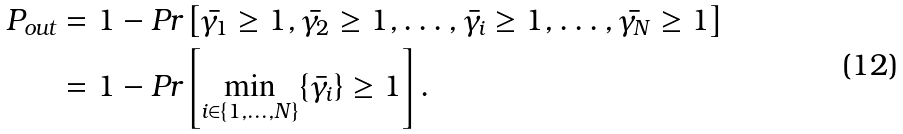<formula> <loc_0><loc_0><loc_500><loc_500>P _ { o u t } & = 1 - P r \left [ \bar { \gamma _ { 1 } } \geq 1 , \bar { \gamma _ { 2 } } \geq 1 , \dots , \bar { \gamma _ { i } } \geq 1 , \dots , \bar { \gamma _ { N } } \geq 1 \right ] \\ & = 1 - P r \left [ { \underset { i \in \{ 1 , \dots , N \} } { \min } } \{ \bar { \gamma _ { i } } \} \geq 1 \right ] .</formula> 